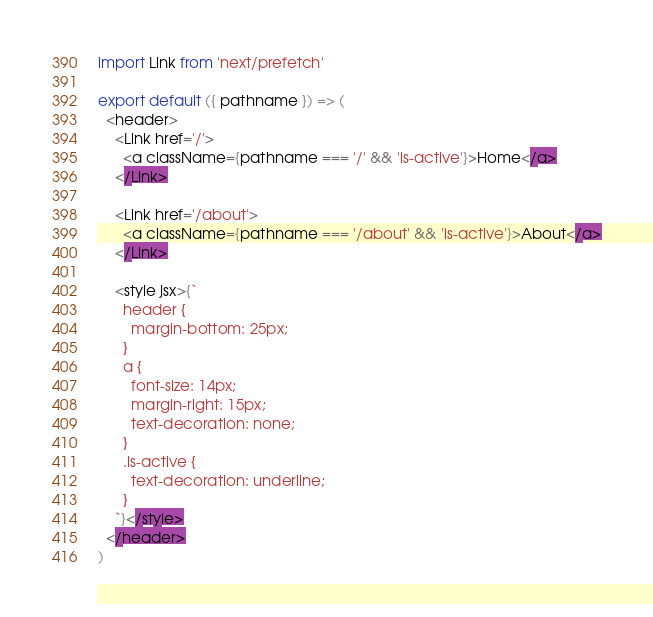<code> <loc_0><loc_0><loc_500><loc_500><_JavaScript_>import Link from 'next/prefetch'

export default ({ pathname }) => (
  <header>
    <Link href='/'>
      <a className={pathname === '/' && 'is-active'}>Home</a>
    </Link>

    <Link href='/about'>
      <a className={pathname === '/about' && 'is-active'}>About</a>
    </Link>

    <style jsx>{`
      header {
        margin-bottom: 25px;
      }
      a {
        font-size: 14px;
        margin-right: 15px;
        text-decoration: none;
      }
      .is-active {
        text-decoration: underline;
      }
    `}</style>
  </header>
)
</code> 